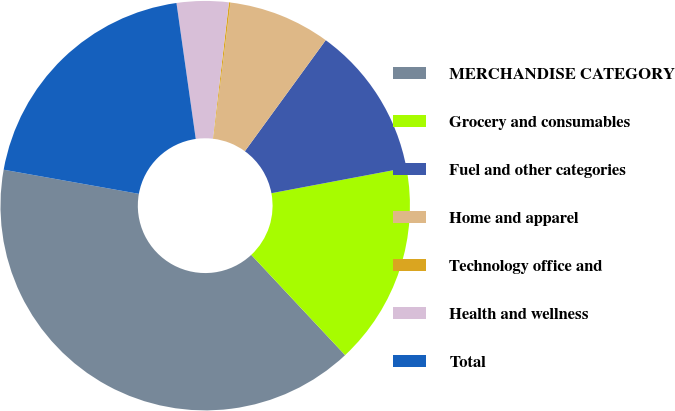Convert chart. <chart><loc_0><loc_0><loc_500><loc_500><pie_chart><fcel>MERCHANDISE CATEGORY<fcel>Grocery and consumables<fcel>Fuel and other categories<fcel>Home and apparel<fcel>Technology office and<fcel>Health and wellness<fcel>Total<nl><fcel>39.79%<fcel>15.99%<fcel>12.02%<fcel>8.05%<fcel>0.12%<fcel>4.09%<fcel>19.95%<nl></chart> 